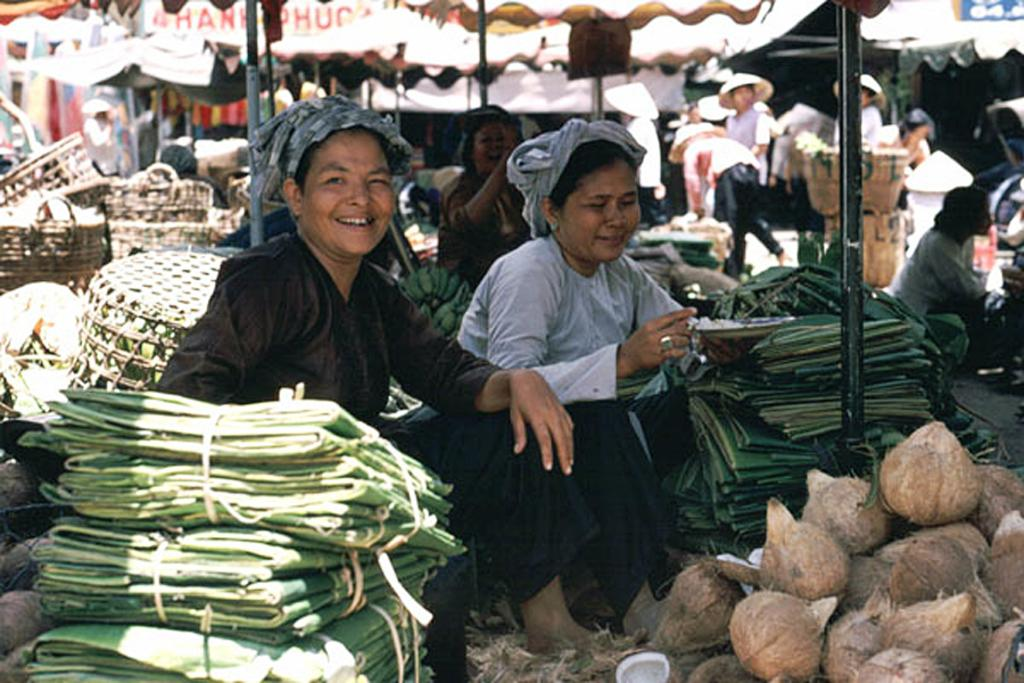How many people are sitting in the image? There are two persons sitting in the image. What objects can be seen in the image besides the people? There are coconuts, green sheets, baskets, and a pole visible in the image. What are the people in the background of the image doing? There are people wearing hats standing in the background of the image. What type of development can be seen taking place in the image? There is no development taking place in the image; it is a static scene featuring people, objects, and a background. 